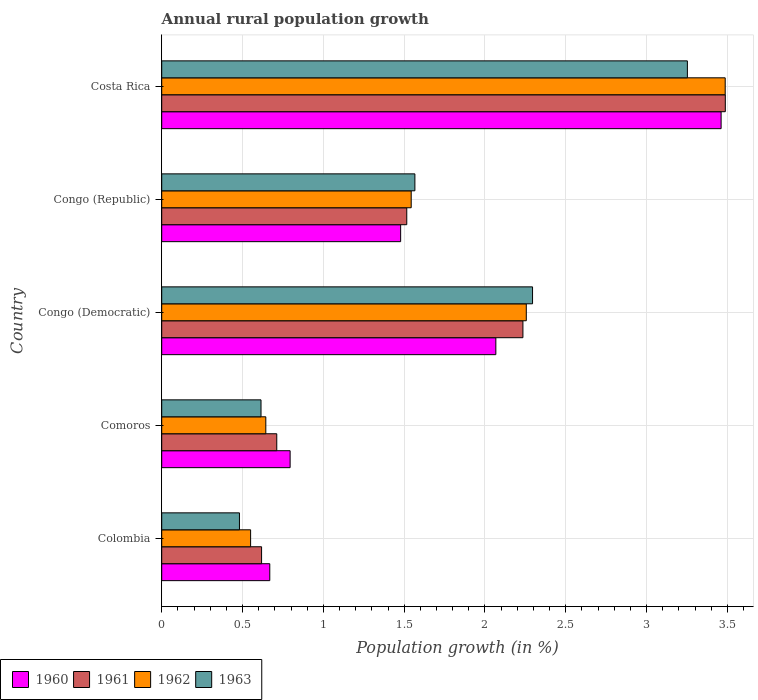How many different coloured bars are there?
Make the answer very short. 4. Are the number of bars on each tick of the Y-axis equal?
Provide a succinct answer. Yes. How many bars are there on the 2nd tick from the top?
Offer a terse response. 4. In how many cases, is the number of bars for a given country not equal to the number of legend labels?
Keep it short and to the point. 0. What is the percentage of rural population growth in 1960 in Comoros?
Ensure brevity in your answer.  0.79. Across all countries, what is the maximum percentage of rural population growth in 1961?
Your answer should be compact. 3.49. Across all countries, what is the minimum percentage of rural population growth in 1960?
Give a very brief answer. 0.67. In which country was the percentage of rural population growth in 1960 maximum?
Give a very brief answer. Costa Rica. What is the total percentage of rural population growth in 1963 in the graph?
Your answer should be very brief. 8.21. What is the difference between the percentage of rural population growth in 1963 in Colombia and that in Costa Rica?
Provide a succinct answer. -2.77. What is the difference between the percentage of rural population growth in 1961 in Comoros and the percentage of rural population growth in 1962 in Congo (Republic)?
Keep it short and to the point. -0.83. What is the average percentage of rural population growth in 1963 per country?
Give a very brief answer. 1.64. What is the difference between the percentage of rural population growth in 1963 and percentage of rural population growth in 1960 in Congo (Democratic)?
Offer a terse response. 0.23. What is the ratio of the percentage of rural population growth in 1963 in Colombia to that in Costa Rica?
Keep it short and to the point. 0.15. Is the percentage of rural population growth in 1960 in Colombia less than that in Comoros?
Provide a succinct answer. Yes. Is the difference between the percentage of rural population growth in 1963 in Congo (Democratic) and Congo (Republic) greater than the difference between the percentage of rural population growth in 1960 in Congo (Democratic) and Congo (Republic)?
Offer a terse response. Yes. What is the difference between the highest and the second highest percentage of rural population growth in 1963?
Make the answer very short. 0.96. What is the difference between the highest and the lowest percentage of rural population growth in 1961?
Offer a very short reply. 2.87. Is the sum of the percentage of rural population growth in 1963 in Comoros and Costa Rica greater than the maximum percentage of rural population growth in 1962 across all countries?
Your answer should be very brief. Yes. What does the 1st bar from the bottom in Congo (Democratic) represents?
Give a very brief answer. 1960. Are all the bars in the graph horizontal?
Ensure brevity in your answer.  Yes. Does the graph contain any zero values?
Ensure brevity in your answer.  No. Does the graph contain grids?
Ensure brevity in your answer.  Yes. Where does the legend appear in the graph?
Give a very brief answer. Bottom left. What is the title of the graph?
Offer a very short reply. Annual rural population growth. Does "1999" appear as one of the legend labels in the graph?
Ensure brevity in your answer.  No. What is the label or title of the X-axis?
Provide a short and direct response. Population growth (in %). What is the label or title of the Y-axis?
Offer a terse response. Country. What is the Population growth (in %) in 1960 in Colombia?
Offer a terse response. 0.67. What is the Population growth (in %) in 1961 in Colombia?
Your answer should be compact. 0.62. What is the Population growth (in %) in 1962 in Colombia?
Make the answer very short. 0.55. What is the Population growth (in %) of 1963 in Colombia?
Your response must be concise. 0.48. What is the Population growth (in %) in 1960 in Comoros?
Provide a succinct answer. 0.79. What is the Population growth (in %) in 1961 in Comoros?
Give a very brief answer. 0.71. What is the Population growth (in %) of 1962 in Comoros?
Offer a very short reply. 0.64. What is the Population growth (in %) of 1963 in Comoros?
Keep it short and to the point. 0.61. What is the Population growth (in %) in 1960 in Congo (Democratic)?
Provide a succinct answer. 2.07. What is the Population growth (in %) in 1961 in Congo (Democratic)?
Ensure brevity in your answer.  2.23. What is the Population growth (in %) of 1962 in Congo (Democratic)?
Offer a terse response. 2.26. What is the Population growth (in %) in 1963 in Congo (Democratic)?
Make the answer very short. 2.29. What is the Population growth (in %) in 1960 in Congo (Republic)?
Offer a terse response. 1.48. What is the Population growth (in %) in 1961 in Congo (Republic)?
Offer a very short reply. 1.52. What is the Population growth (in %) in 1962 in Congo (Republic)?
Provide a short and direct response. 1.54. What is the Population growth (in %) of 1963 in Congo (Republic)?
Provide a short and direct response. 1.57. What is the Population growth (in %) in 1960 in Costa Rica?
Give a very brief answer. 3.46. What is the Population growth (in %) of 1961 in Costa Rica?
Provide a short and direct response. 3.49. What is the Population growth (in %) of 1962 in Costa Rica?
Give a very brief answer. 3.49. What is the Population growth (in %) of 1963 in Costa Rica?
Your response must be concise. 3.25. Across all countries, what is the maximum Population growth (in %) in 1960?
Your answer should be compact. 3.46. Across all countries, what is the maximum Population growth (in %) of 1961?
Make the answer very short. 3.49. Across all countries, what is the maximum Population growth (in %) of 1962?
Your answer should be compact. 3.49. Across all countries, what is the maximum Population growth (in %) of 1963?
Provide a succinct answer. 3.25. Across all countries, what is the minimum Population growth (in %) of 1960?
Make the answer very short. 0.67. Across all countries, what is the minimum Population growth (in %) of 1961?
Your response must be concise. 0.62. Across all countries, what is the minimum Population growth (in %) in 1962?
Provide a short and direct response. 0.55. Across all countries, what is the minimum Population growth (in %) of 1963?
Keep it short and to the point. 0.48. What is the total Population growth (in %) of 1960 in the graph?
Keep it short and to the point. 8.47. What is the total Population growth (in %) in 1961 in the graph?
Your answer should be very brief. 8.57. What is the total Population growth (in %) of 1962 in the graph?
Keep it short and to the point. 8.48. What is the total Population growth (in %) in 1963 in the graph?
Provide a succinct answer. 8.21. What is the difference between the Population growth (in %) of 1960 in Colombia and that in Comoros?
Keep it short and to the point. -0.13. What is the difference between the Population growth (in %) in 1961 in Colombia and that in Comoros?
Provide a succinct answer. -0.09. What is the difference between the Population growth (in %) in 1962 in Colombia and that in Comoros?
Your answer should be compact. -0.09. What is the difference between the Population growth (in %) in 1963 in Colombia and that in Comoros?
Your response must be concise. -0.13. What is the difference between the Population growth (in %) in 1960 in Colombia and that in Congo (Democratic)?
Provide a succinct answer. -1.4. What is the difference between the Population growth (in %) of 1961 in Colombia and that in Congo (Democratic)?
Your answer should be compact. -1.62. What is the difference between the Population growth (in %) in 1962 in Colombia and that in Congo (Democratic)?
Give a very brief answer. -1.71. What is the difference between the Population growth (in %) in 1963 in Colombia and that in Congo (Democratic)?
Your answer should be very brief. -1.81. What is the difference between the Population growth (in %) in 1960 in Colombia and that in Congo (Republic)?
Give a very brief answer. -0.81. What is the difference between the Population growth (in %) in 1961 in Colombia and that in Congo (Republic)?
Your response must be concise. -0.9. What is the difference between the Population growth (in %) in 1962 in Colombia and that in Congo (Republic)?
Your answer should be compact. -0.99. What is the difference between the Population growth (in %) of 1963 in Colombia and that in Congo (Republic)?
Provide a succinct answer. -1.09. What is the difference between the Population growth (in %) in 1960 in Colombia and that in Costa Rica?
Provide a succinct answer. -2.79. What is the difference between the Population growth (in %) of 1961 in Colombia and that in Costa Rica?
Your answer should be very brief. -2.87. What is the difference between the Population growth (in %) of 1962 in Colombia and that in Costa Rica?
Provide a succinct answer. -2.94. What is the difference between the Population growth (in %) in 1963 in Colombia and that in Costa Rica?
Make the answer very short. -2.77. What is the difference between the Population growth (in %) in 1960 in Comoros and that in Congo (Democratic)?
Offer a terse response. -1.27. What is the difference between the Population growth (in %) in 1961 in Comoros and that in Congo (Democratic)?
Offer a terse response. -1.52. What is the difference between the Population growth (in %) in 1962 in Comoros and that in Congo (Democratic)?
Your response must be concise. -1.61. What is the difference between the Population growth (in %) of 1963 in Comoros and that in Congo (Democratic)?
Your response must be concise. -1.68. What is the difference between the Population growth (in %) of 1960 in Comoros and that in Congo (Republic)?
Offer a very short reply. -0.68. What is the difference between the Population growth (in %) of 1961 in Comoros and that in Congo (Republic)?
Provide a succinct answer. -0.8. What is the difference between the Population growth (in %) in 1962 in Comoros and that in Congo (Republic)?
Ensure brevity in your answer.  -0.9. What is the difference between the Population growth (in %) of 1963 in Comoros and that in Congo (Republic)?
Give a very brief answer. -0.95. What is the difference between the Population growth (in %) in 1960 in Comoros and that in Costa Rica?
Make the answer very short. -2.67. What is the difference between the Population growth (in %) of 1961 in Comoros and that in Costa Rica?
Your answer should be compact. -2.78. What is the difference between the Population growth (in %) of 1962 in Comoros and that in Costa Rica?
Offer a terse response. -2.84. What is the difference between the Population growth (in %) in 1963 in Comoros and that in Costa Rica?
Your response must be concise. -2.64. What is the difference between the Population growth (in %) in 1960 in Congo (Democratic) and that in Congo (Republic)?
Make the answer very short. 0.59. What is the difference between the Population growth (in %) of 1961 in Congo (Democratic) and that in Congo (Republic)?
Your response must be concise. 0.72. What is the difference between the Population growth (in %) in 1962 in Congo (Democratic) and that in Congo (Republic)?
Ensure brevity in your answer.  0.71. What is the difference between the Population growth (in %) in 1963 in Congo (Democratic) and that in Congo (Republic)?
Ensure brevity in your answer.  0.73. What is the difference between the Population growth (in %) of 1960 in Congo (Democratic) and that in Costa Rica?
Ensure brevity in your answer.  -1.39. What is the difference between the Population growth (in %) in 1961 in Congo (Democratic) and that in Costa Rica?
Make the answer very short. -1.25. What is the difference between the Population growth (in %) of 1962 in Congo (Democratic) and that in Costa Rica?
Give a very brief answer. -1.23. What is the difference between the Population growth (in %) of 1963 in Congo (Democratic) and that in Costa Rica?
Your answer should be compact. -0.96. What is the difference between the Population growth (in %) in 1960 in Congo (Republic) and that in Costa Rica?
Your answer should be compact. -1.98. What is the difference between the Population growth (in %) in 1961 in Congo (Republic) and that in Costa Rica?
Your answer should be compact. -1.97. What is the difference between the Population growth (in %) in 1962 in Congo (Republic) and that in Costa Rica?
Keep it short and to the point. -1.94. What is the difference between the Population growth (in %) of 1963 in Congo (Republic) and that in Costa Rica?
Ensure brevity in your answer.  -1.69. What is the difference between the Population growth (in %) of 1960 in Colombia and the Population growth (in %) of 1961 in Comoros?
Give a very brief answer. -0.04. What is the difference between the Population growth (in %) in 1960 in Colombia and the Population growth (in %) in 1962 in Comoros?
Offer a terse response. 0.02. What is the difference between the Population growth (in %) in 1960 in Colombia and the Population growth (in %) in 1963 in Comoros?
Make the answer very short. 0.05. What is the difference between the Population growth (in %) in 1961 in Colombia and the Population growth (in %) in 1962 in Comoros?
Ensure brevity in your answer.  -0.03. What is the difference between the Population growth (in %) of 1961 in Colombia and the Population growth (in %) of 1963 in Comoros?
Ensure brevity in your answer.  0. What is the difference between the Population growth (in %) in 1962 in Colombia and the Population growth (in %) in 1963 in Comoros?
Offer a very short reply. -0.06. What is the difference between the Population growth (in %) in 1960 in Colombia and the Population growth (in %) in 1961 in Congo (Democratic)?
Keep it short and to the point. -1.57. What is the difference between the Population growth (in %) of 1960 in Colombia and the Population growth (in %) of 1962 in Congo (Democratic)?
Your response must be concise. -1.59. What is the difference between the Population growth (in %) of 1960 in Colombia and the Population growth (in %) of 1963 in Congo (Democratic)?
Your response must be concise. -1.63. What is the difference between the Population growth (in %) of 1961 in Colombia and the Population growth (in %) of 1962 in Congo (Democratic)?
Make the answer very short. -1.64. What is the difference between the Population growth (in %) in 1961 in Colombia and the Population growth (in %) in 1963 in Congo (Democratic)?
Keep it short and to the point. -1.68. What is the difference between the Population growth (in %) of 1962 in Colombia and the Population growth (in %) of 1963 in Congo (Democratic)?
Offer a very short reply. -1.74. What is the difference between the Population growth (in %) of 1960 in Colombia and the Population growth (in %) of 1961 in Congo (Republic)?
Keep it short and to the point. -0.85. What is the difference between the Population growth (in %) in 1960 in Colombia and the Population growth (in %) in 1962 in Congo (Republic)?
Give a very brief answer. -0.87. What is the difference between the Population growth (in %) of 1960 in Colombia and the Population growth (in %) of 1963 in Congo (Republic)?
Make the answer very short. -0.9. What is the difference between the Population growth (in %) of 1961 in Colombia and the Population growth (in %) of 1962 in Congo (Republic)?
Offer a very short reply. -0.93. What is the difference between the Population growth (in %) in 1961 in Colombia and the Population growth (in %) in 1963 in Congo (Republic)?
Offer a very short reply. -0.95. What is the difference between the Population growth (in %) of 1962 in Colombia and the Population growth (in %) of 1963 in Congo (Republic)?
Your response must be concise. -1.02. What is the difference between the Population growth (in %) of 1960 in Colombia and the Population growth (in %) of 1961 in Costa Rica?
Offer a very short reply. -2.82. What is the difference between the Population growth (in %) in 1960 in Colombia and the Population growth (in %) in 1962 in Costa Rica?
Your response must be concise. -2.82. What is the difference between the Population growth (in %) of 1960 in Colombia and the Population growth (in %) of 1963 in Costa Rica?
Your response must be concise. -2.58. What is the difference between the Population growth (in %) of 1961 in Colombia and the Population growth (in %) of 1962 in Costa Rica?
Keep it short and to the point. -2.87. What is the difference between the Population growth (in %) of 1961 in Colombia and the Population growth (in %) of 1963 in Costa Rica?
Offer a terse response. -2.63. What is the difference between the Population growth (in %) of 1962 in Colombia and the Population growth (in %) of 1963 in Costa Rica?
Your response must be concise. -2.7. What is the difference between the Population growth (in %) of 1960 in Comoros and the Population growth (in %) of 1961 in Congo (Democratic)?
Ensure brevity in your answer.  -1.44. What is the difference between the Population growth (in %) in 1960 in Comoros and the Population growth (in %) in 1962 in Congo (Democratic)?
Make the answer very short. -1.46. What is the difference between the Population growth (in %) of 1960 in Comoros and the Population growth (in %) of 1963 in Congo (Democratic)?
Offer a very short reply. -1.5. What is the difference between the Population growth (in %) of 1961 in Comoros and the Population growth (in %) of 1962 in Congo (Democratic)?
Make the answer very short. -1.54. What is the difference between the Population growth (in %) in 1961 in Comoros and the Population growth (in %) in 1963 in Congo (Democratic)?
Offer a terse response. -1.58. What is the difference between the Population growth (in %) of 1962 in Comoros and the Population growth (in %) of 1963 in Congo (Democratic)?
Provide a succinct answer. -1.65. What is the difference between the Population growth (in %) in 1960 in Comoros and the Population growth (in %) in 1961 in Congo (Republic)?
Your answer should be compact. -0.72. What is the difference between the Population growth (in %) of 1960 in Comoros and the Population growth (in %) of 1962 in Congo (Republic)?
Provide a short and direct response. -0.75. What is the difference between the Population growth (in %) in 1960 in Comoros and the Population growth (in %) in 1963 in Congo (Republic)?
Make the answer very short. -0.77. What is the difference between the Population growth (in %) in 1961 in Comoros and the Population growth (in %) in 1962 in Congo (Republic)?
Your answer should be compact. -0.83. What is the difference between the Population growth (in %) in 1961 in Comoros and the Population growth (in %) in 1963 in Congo (Republic)?
Offer a very short reply. -0.85. What is the difference between the Population growth (in %) of 1962 in Comoros and the Population growth (in %) of 1963 in Congo (Republic)?
Your answer should be very brief. -0.92. What is the difference between the Population growth (in %) of 1960 in Comoros and the Population growth (in %) of 1961 in Costa Rica?
Provide a succinct answer. -2.69. What is the difference between the Population growth (in %) of 1960 in Comoros and the Population growth (in %) of 1962 in Costa Rica?
Your response must be concise. -2.69. What is the difference between the Population growth (in %) in 1960 in Comoros and the Population growth (in %) in 1963 in Costa Rica?
Make the answer very short. -2.46. What is the difference between the Population growth (in %) of 1961 in Comoros and the Population growth (in %) of 1962 in Costa Rica?
Provide a short and direct response. -2.77. What is the difference between the Population growth (in %) of 1961 in Comoros and the Population growth (in %) of 1963 in Costa Rica?
Keep it short and to the point. -2.54. What is the difference between the Population growth (in %) of 1962 in Comoros and the Population growth (in %) of 1963 in Costa Rica?
Your response must be concise. -2.61. What is the difference between the Population growth (in %) of 1960 in Congo (Democratic) and the Population growth (in %) of 1961 in Congo (Republic)?
Provide a short and direct response. 0.55. What is the difference between the Population growth (in %) in 1960 in Congo (Democratic) and the Population growth (in %) in 1962 in Congo (Republic)?
Your response must be concise. 0.52. What is the difference between the Population growth (in %) in 1960 in Congo (Democratic) and the Population growth (in %) in 1963 in Congo (Republic)?
Provide a short and direct response. 0.5. What is the difference between the Population growth (in %) of 1961 in Congo (Democratic) and the Population growth (in %) of 1962 in Congo (Republic)?
Provide a short and direct response. 0.69. What is the difference between the Population growth (in %) in 1961 in Congo (Democratic) and the Population growth (in %) in 1963 in Congo (Republic)?
Offer a very short reply. 0.67. What is the difference between the Population growth (in %) of 1962 in Congo (Democratic) and the Population growth (in %) of 1963 in Congo (Republic)?
Offer a terse response. 0.69. What is the difference between the Population growth (in %) of 1960 in Congo (Democratic) and the Population growth (in %) of 1961 in Costa Rica?
Provide a short and direct response. -1.42. What is the difference between the Population growth (in %) of 1960 in Congo (Democratic) and the Population growth (in %) of 1962 in Costa Rica?
Keep it short and to the point. -1.42. What is the difference between the Population growth (in %) in 1960 in Congo (Democratic) and the Population growth (in %) in 1963 in Costa Rica?
Keep it short and to the point. -1.19. What is the difference between the Population growth (in %) of 1961 in Congo (Democratic) and the Population growth (in %) of 1962 in Costa Rica?
Your response must be concise. -1.25. What is the difference between the Population growth (in %) of 1961 in Congo (Democratic) and the Population growth (in %) of 1963 in Costa Rica?
Offer a terse response. -1.02. What is the difference between the Population growth (in %) in 1962 in Congo (Democratic) and the Population growth (in %) in 1963 in Costa Rica?
Your answer should be compact. -1. What is the difference between the Population growth (in %) in 1960 in Congo (Republic) and the Population growth (in %) in 1961 in Costa Rica?
Make the answer very short. -2.01. What is the difference between the Population growth (in %) in 1960 in Congo (Republic) and the Population growth (in %) in 1962 in Costa Rica?
Your answer should be compact. -2.01. What is the difference between the Population growth (in %) of 1960 in Congo (Republic) and the Population growth (in %) of 1963 in Costa Rica?
Offer a very short reply. -1.77. What is the difference between the Population growth (in %) of 1961 in Congo (Republic) and the Population growth (in %) of 1962 in Costa Rica?
Your answer should be compact. -1.97. What is the difference between the Population growth (in %) in 1961 in Congo (Republic) and the Population growth (in %) in 1963 in Costa Rica?
Ensure brevity in your answer.  -1.74. What is the difference between the Population growth (in %) of 1962 in Congo (Republic) and the Population growth (in %) of 1963 in Costa Rica?
Offer a terse response. -1.71. What is the average Population growth (in %) in 1960 per country?
Ensure brevity in your answer.  1.69. What is the average Population growth (in %) of 1961 per country?
Provide a short and direct response. 1.71. What is the average Population growth (in %) of 1962 per country?
Provide a succinct answer. 1.7. What is the average Population growth (in %) of 1963 per country?
Keep it short and to the point. 1.64. What is the difference between the Population growth (in %) in 1960 and Population growth (in %) in 1961 in Colombia?
Your answer should be compact. 0.05. What is the difference between the Population growth (in %) of 1960 and Population growth (in %) of 1962 in Colombia?
Give a very brief answer. 0.12. What is the difference between the Population growth (in %) in 1960 and Population growth (in %) in 1963 in Colombia?
Keep it short and to the point. 0.19. What is the difference between the Population growth (in %) in 1961 and Population growth (in %) in 1962 in Colombia?
Give a very brief answer. 0.07. What is the difference between the Population growth (in %) in 1961 and Population growth (in %) in 1963 in Colombia?
Provide a succinct answer. 0.14. What is the difference between the Population growth (in %) of 1962 and Population growth (in %) of 1963 in Colombia?
Provide a short and direct response. 0.07. What is the difference between the Population growth (in %) in 1960 and Population growth (in %) in 1961 in Comoros?
Give a very brief answer. 0.08. What is the difference between the Population growth (in %) in 1960 and Population growth (in %) in 1962 in Comoros?
Your response must be concise. 0.15. What is the difference between the Population growth (in %) in 1960 and Population growth (in %) in 1963 in Comoros?
Provide a short and direct response. 0.18. What is the difference between the Population growth (in %) in 1961 and Population growth (in %) in 1962 in Comoros?
Your response must be concise. 0.07. What is the difference between the Population growth (in %) in 1961 and Population growth (in %) in 1963 in Comoros?
Provide a short and direct response. 0.1. What is the difference between the Population growth (in %) of 1962 and Population growth (in %) of 1963 in Comoros?
Ensure brevity in your answer.  0.03. What is the difference between the Population growth (in %) of 1960 and Population growth (in %) of 1961 in Congo (Democratic)?
Provide a succinct answer. -0.17. What is the difference between the Population growth (in %) of 1960 and Population growth (in %) of 1962 in Congo (Democratic)?
Make the answer very short. -0.19. What is the difference between the Population growth (in %) of 1960 and Population growth (in %) of 1963 in Congo (Democratic)?
Your answer should be very brief. -0.23. What is the difference between the Population growth (in %) of 1961 and Population growth (in %) of 1962 in Congo (Democratic)?
Offer a very short reply. -0.02. What is the difference between the Population growth (in %) of 1961 and Population growth (in %) of 1963 in Congo (Democratic)?
Ensure brevity in your answer.  -0.06. What is the difference between the Population growth (in %) of 1962 and Population growth (in %) of 1963 in Congo (Democratic)?
Keep it short and to the point. -0.04. What is the difference between the Population growth (in %) in 1960 and Population growth (in %) in 1961 in Congo (Republic)?
Make the answer very short. -0.04. What is the difference between the Population growth (in %) of 1960 and Population growth (in %) of 1962 in Congo (Republic)?
Ensure brevity in your answer.  -0.07. What is the difference between the Population growth (in %) in 1960 and Population growth (in %) in 1963 in Congo (Republic)?
Give a very brief answer. -0.09. What is the difference between the Population growth (in %) of 1961 and Population growth (in %) of 1962 in Congo (Republic)?
Ensure brevity in your answer.  -0.03. What is the difference between the Population growth (in %) of 1961 and Population growth (in %) of 1963 in Congo (Republic)?
Give a very brief answer. -0.05. What is the difference between the Population growth (in %) in 1962 and Population growth (in %) in 1963 in Congo (Republic)?
Offer a very short reply. -0.02. What is the difference between the Population growth (in %) of 1960 and Population growth (in %) of 1961 in Costa Rica?
Make the answer very short. -0.03. What is the difference between the Population growth (in %) in 1960 and Population growth (in %) in 1962 in Costa Rica?
Give a very brief answer. -0.03. What is the difference between the Population growth (in %) of 1960 and Population growth (in %) of 1963 in Costa Rica?
Offer a terse response. 0.21. What is the difference between the Population growth (in %) in 1961 and Population growth (in %) in 1962 in Costa Rica?
Provide a succinct answer. 0. What is the difference between the Population growth (in %) of 1961 and Population growth (in %) of 1963 in Costa Rica?
Your answer should be very brief. 0.23. What is the difference between the Population growth (in %) in 1962 and Population growth (in %) in 1963 in Costa Rica?
Your response must be concise. 0.23. What is the ratio of the Population growth (in %) of 1960 in Colombia to that in Comoros?
Offer a very short reply. 0.84. What is the ratio of the Population growth (in %) of 1961 in Colombia to that in Comoros?
Offer a terse response. 0.87. What is the ratio of the Population growth (in %) in 1962 in Colombia to that in Comoros?
Provide a succinct answer. 0.85. What is the ratio of the Population growth (in %) in 1963 in Colombia to that in Comoros?
Offer a very short reply. 0.78. What is the ratio of the Population growth (in %) of 1960 in Colombia to that in Congo (Democratic)?
Make the answer very short. 0.32. What is the ratio of the Population growth (in %) of 1961 in Colombia to that in Congo (Democratic)?
Ensure brevity in your answer.  0.28. What is the ratio of the Population growth (in %) of 1962 in Colombia to that in Congo (Democratic)?
Offer a very short reply. 0.24. What is the ratio of the Population growth (in %) of 1963 in Colombia to that in Congo (Democratic)?
Offer a terse response. 0.21. What is the ratio of the Population growth (in %) of 1960 in Colombia to that in Congo (Republic)?
Your answer should be very brief. 0.45. What is the ratio of the Population growth (in %) of 1961 in Colombia to that in Congo (Republic)?
Keep it short and to the point. 0.41. What is the ratio of the Population growth (in %) in 1962 in Colombia to that in Congo (Republic)?
Provide a succinct answer. 0.36. What is the ratio of the Population growth (in %) of 1963 in Colombia to that in Congo (Republic)?
Keep it short and to the point. 0.31. What is the ratio of the Population growth (in %) of 1960 in Colombia to that in Costa Rica?
Ensure brevity in your answer.  0.19. What is the ratio of the Population growth (in %) in 1961 in Colombia to that in Costa Rica?
Give a very brief answer. 0.18. What is the ratio of the Population growth (in %) of 1962 in Colombia to that in Costa Rica?
Provide a succinct answer. 0.16. What is the ratio of the Population growth (in %) in 1963 in Colombia to that in Costa Rica?
Ensure brevity in your answer.  0.15. What is the ratio of the Population growth (in %) of 1960 in Comoros to that in Congo (Democratic)?
Offer a very short reply. 0.38. What is the ratio of the Population growth (in %) of 1961 in Comoros to that in Congo (Democratic)?
Give a very brief answer. 0.32. What is the ratio of the Population growth (in %) of 1962 in Comoros to that in Congo (Democratic)?
Offer a very short reply. 0.29. What is the ratio of the Population growth (in %) of 1963 in Comoros to that in Congo (Democratic)?
Your response must be concise. 0.27. What is the ratio of the Population growth (in %) in 1960 in Comoros to that in Congo (Republic)?
Your response must be concise. 0.54. What is the ratio of the Population growth (in %) of 1961 in Comoros to that in Congo (Republic)?
Make the answer very short. 0.47. What is the ratio of the Population growth (in %) of 1962 in Comoros to that in Congo (Republic)?
Your answer should be very brief. 0.42. What is the ratio of the Population growth (in %) in 1963 in Comoros to that in Congo (Republic)?
Your response must be concise. 0.39. What is the ratio of the Population growth (in %) in 1960 in Comoros to that in Costa Rica?
Your response must be concise. 0.23. What is the ratio of the Population growth (in %) of 1961 in Comoros to that in Costa Rica?
Provide a short and direct response. 0.2. What is the ratio of the Population growth (in %) of 1962 in Comoros to that in Costa Rica?
Provide a short and direct response. 0.18. What is the ratio of the Population growth (in %) in 1963 in Comoros to that in Costa Rica?
Provide a short and direct response. 0.19. What is the ratio of the Population growth (in %) of 1960 in Congo (Democratic) to that in Congo (Republic)?
Provide a short and direct response. 1.4. What is the ratio of the Population growth (in %) of 1961 in Congo (Democratic) to that in Congo (Republic)?
Provide a succinct answer. 1.47. What is the ratio of the Population growth (in %) in 1962 in Congo (Democratic) to that in Congo (Republic)?
Provide a short and direct response. 1.46. What is the ratio of the Population growth (in %) of 1963 in Congo (Democratic) to that in Congo (Republic)?
Keep it short and to the point. 1.46. What is the ratio of the Population growth (in %) of 1960 in Congo (Democratic) to that in Costa Rica?
Provide a succinct answer. 0.6. What is the ratio of the Population growth (in %) in 1961 in Congo (Democratic) to that in Costa Rica?
Offer a very short reply. 0.64. What is the ratio of the Population growth (in %) of 1962 in Congo (Democratic) to that in Costa Rica?
Give a very brief answer. 0.65. What is the ratio of the Population growth (in %) in 1963 in Congo (Democratic) to that in Costa Rica?
Ensure brevity in your answer.  0.71. What is the ratio of the Population growth (in %) of 1960 in Congo (Republic) to that in Costa Rica?
Give a very brief answer. 0.43. What is the ratio of the Population growth (in %) in 1961 in Congo (Republic) to that in Costa Rica?
Give a very brief answer. 0.43. What is the ratio of the Population growth (in %) of 1962 in Congo (Republic) to that in Costa Rica?
Your response must be concise. 0.44. What is the ratio of the Population growth (in %) of 1963 in Congo (Republic) to that in Costa Rica?
Offer a very short reply. 0.48. What is the difference between the highest and the second highest Population growth (in %) in 1960?
Make the answer very short. 1.39. What is the difference between the highest and the second highest Population growth (in %) of 1961?
Keep it short and to the point. 1.25. What is the difference between the highest and the second highest Population growth (in %) in 1962?
Provide a succinct answer. 1.23. What is the difference between the highest and the second highest Population growth (in %) in 1963?
Keep it short and to the point. 0.96. What is the difference between the highest and the lowest Population growth (in %) in 1960?
Offer a terse response. 2.79. What is the difference between the highest and the lowest Population growth (in %) in 1961?
Your response must be concise. 2.87. What is the difference between the highest and the lowest Population growth (in %) in 1962?
Offer a terse response. 2.94. What is the difference between the highest and the lowest Population growth (in %) of 1963?
Offer a very short reply. 2.77. 